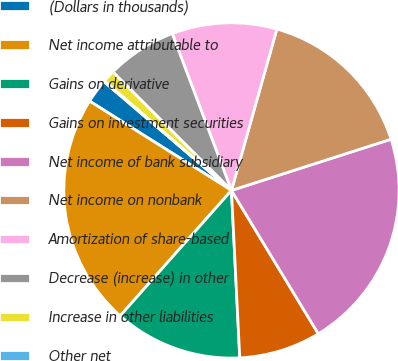Convert chart to OTSL. <chart><loc_0><loc_0><loc_500><loc_500><pie_chart><fcel>(Dollars in thousands)<fcel>Net income attributable to<fcel>Gains on derivative<fcel>Gains on investment securities<fcel>Net income of bank subsidiary<fcel>Net income on nonbank<fcel>Amortization of share-based<fcel>Decrease (increase) in other<fcel>Increase in other liabilities<fcel>Other net<nl><fcel>2.3%<fcel>22.39%<fcel>12.34%<fcel>7.88%<fcel>21.27%<fcel>15.69%<fcel>10.11%<fcel>6.76%<fcel>1.18%<fcel>0.07%<nl></chart> 